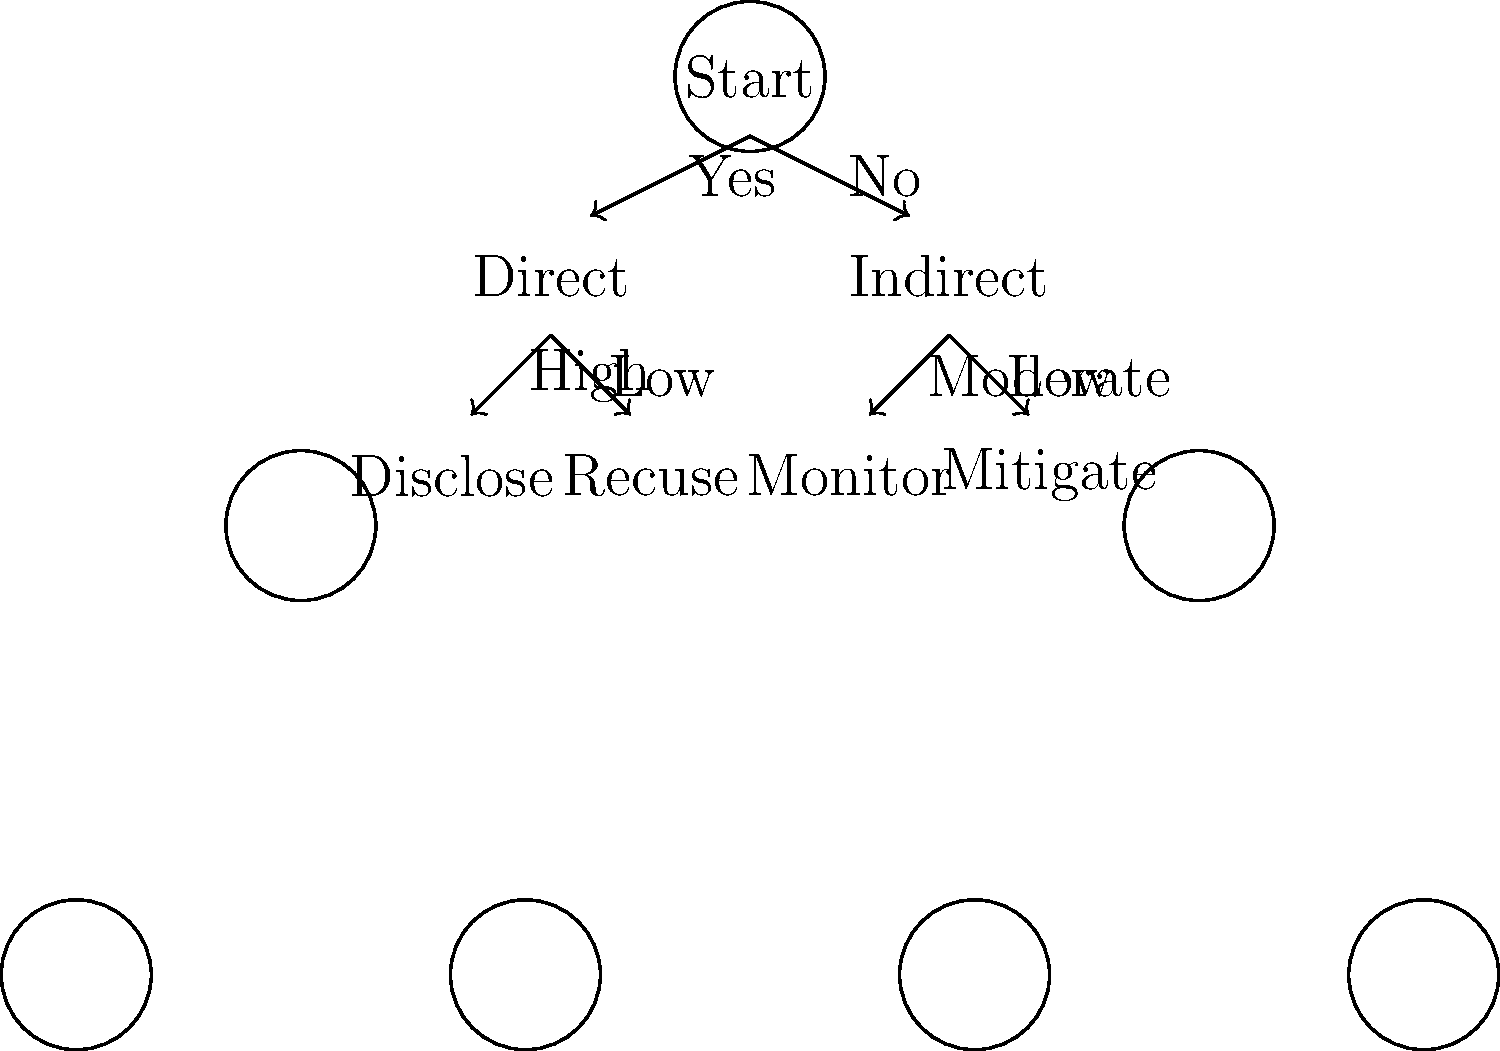Given the decision tree for handling conflicts of interest, what is the appropriate action when faced with an indirect conflict of interest that is assessed to be of moderate risk? To determine the appropriate action for an indirect conflict of interest with moderate risk, we need to follow the decision tree step-by-step:

1. Start at the top of the tree with "Start".
2. The first decision point asks if the conflict is direct or indirect. In this case, it's indirect, so we follow the "No" branch to the right.
3. We arrive at the "Indirect" node, which then branches based on the level of risk.
4. The question states that the risk is moderate, so we follow the "Moderate" branch.
5. This leads us to the "Monitor" action.

Therefore, for an indirect conflict of interest with moderate risk, the appropriate action according to this decision tree is to monitor the situation.

This approach allows for ongoing awareness and management of the potential conflict without necessarily requiring immediate recusal or mitigation, which might be more appropriate for higher-risk scenarios.
Answer: Monitor 